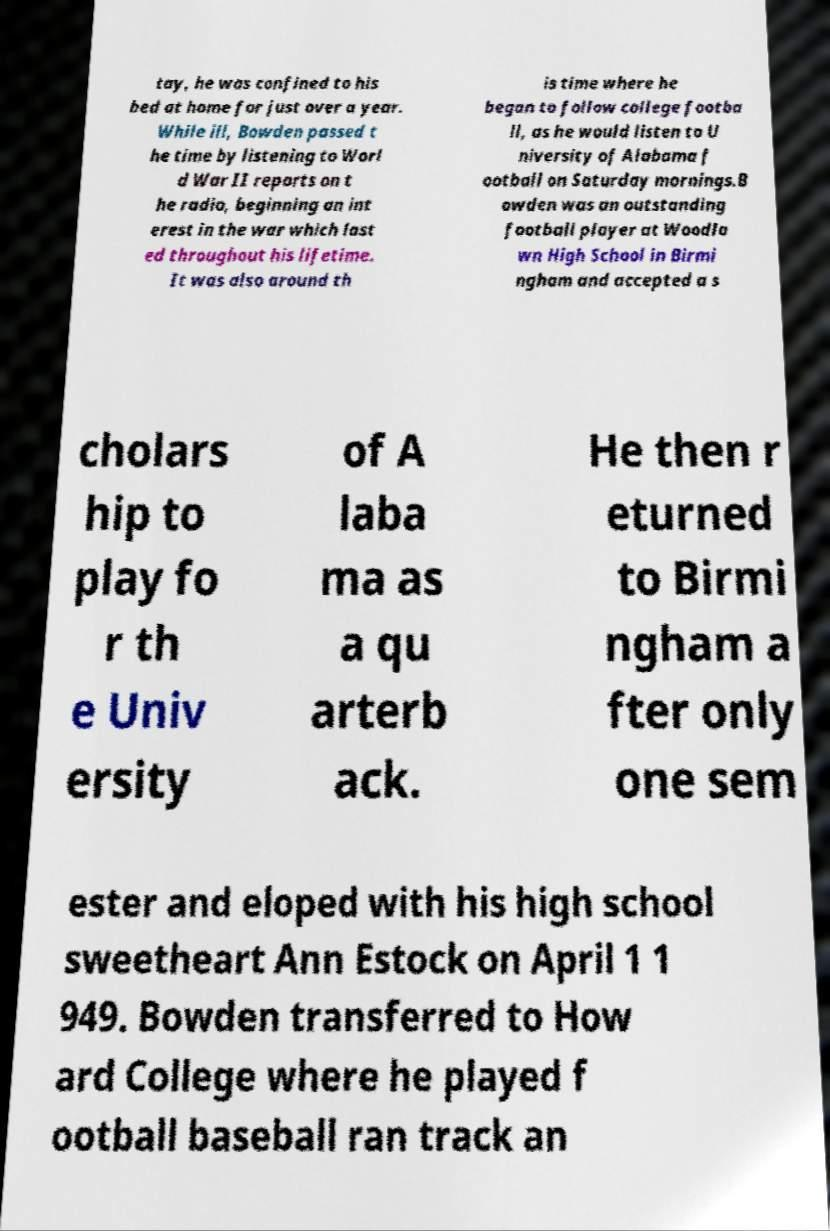There's text embedded in this image that I need extracted. Can you transcribe it verbatim? tay, he was confined to his bed at home for just over a year. While ill, Bowden passed t he time by listening to Worl d War II reports on t he radio, beginning an int erest in the war which last ed throughout his lifetime. It was also around th is time where he began to follow college footba ll, as he would listen to U niversity of Alabama f ootball on Saturday mornings.B owden was an outstanding football player at Woodla wn High School in Birmi ngham and accepted a s cholars hip to play fo r th e Univ ersity of A laba ma as a qu arterb ack. He then r eturned to Birmi ngham a fter only one sem ester and eloped with his high school sweetheart Ann Estock on April 1 1 949. Bowden transferred to How ard College where he played f ootball baseball ran track an 